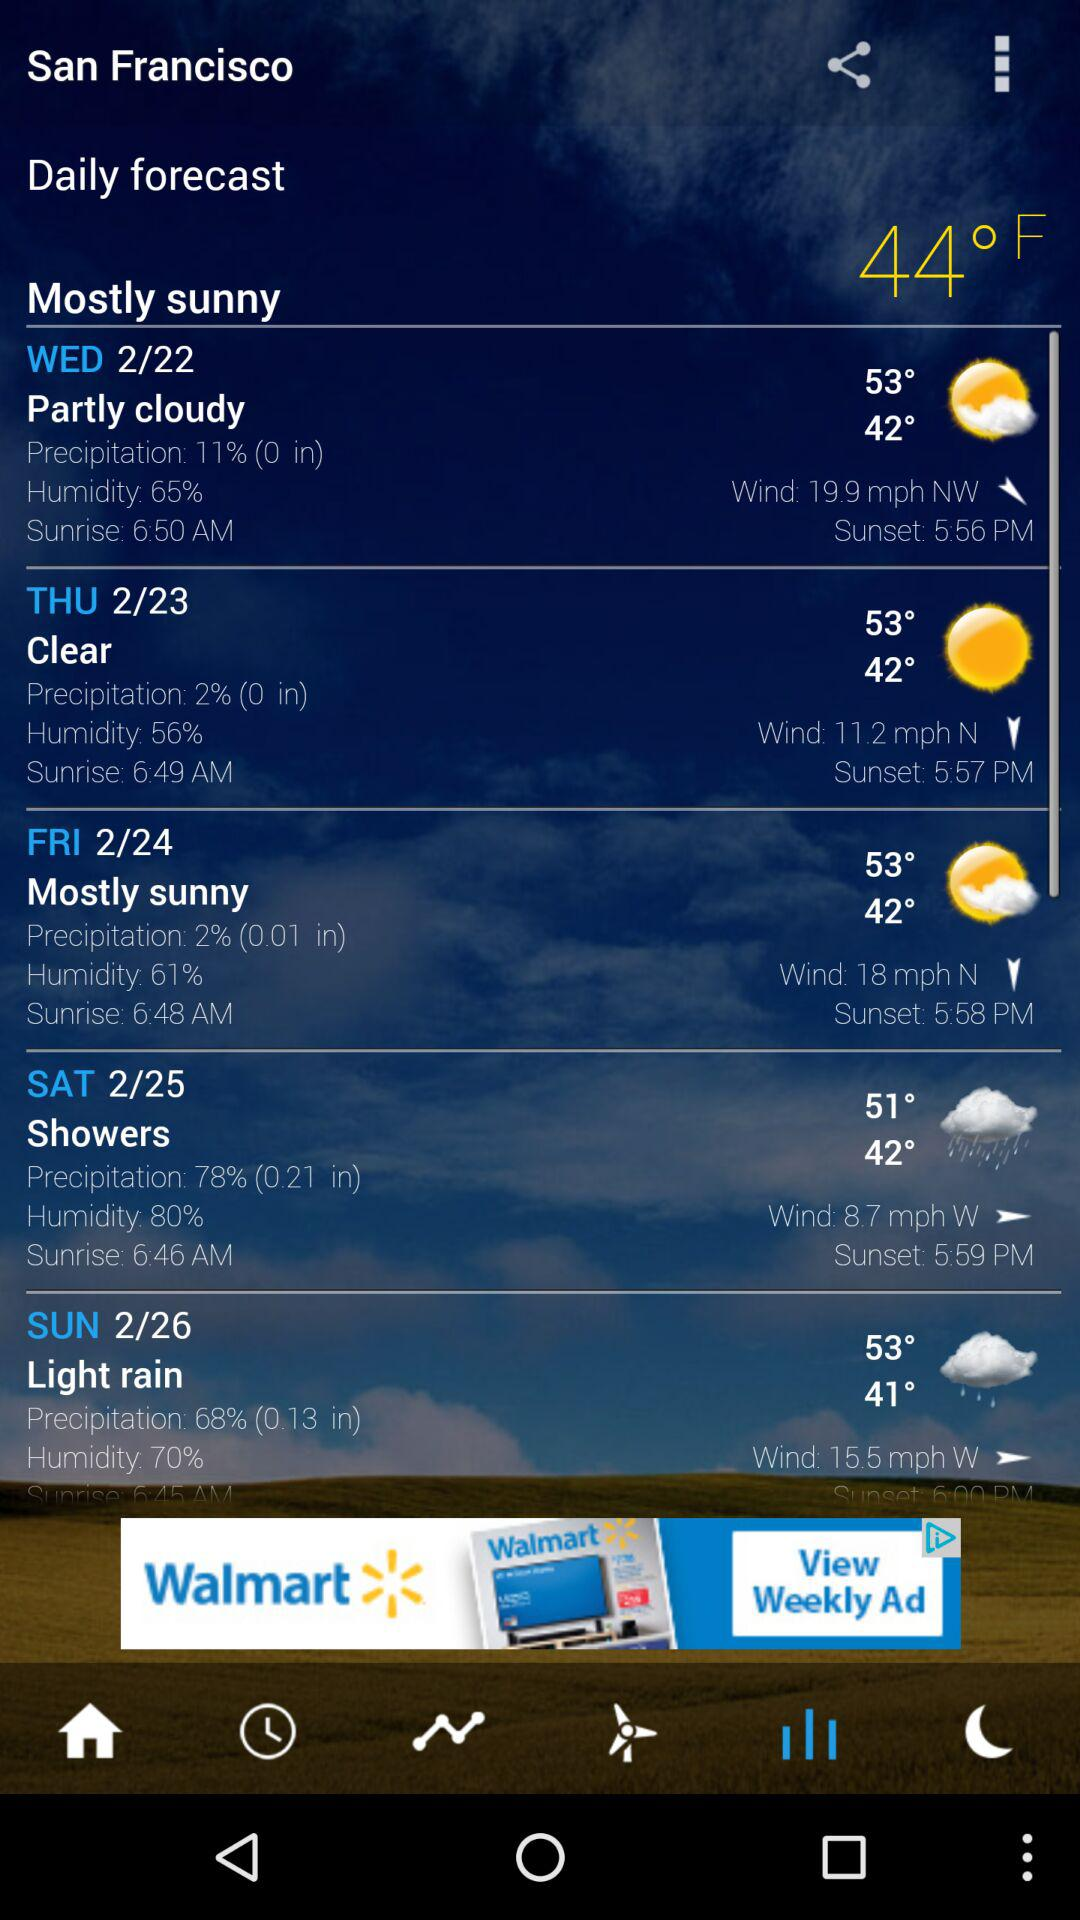What is the unit of precipitation? The unit of precipitation is inches. 